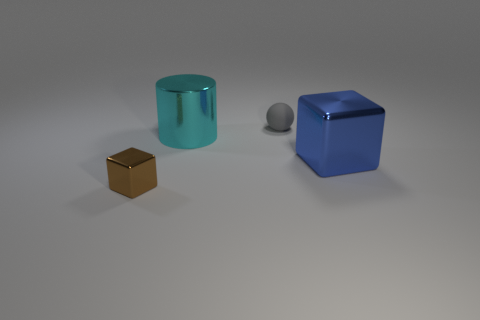Add 4 small gray cylinders. How many objects exist? 8 Subtract 1 cubes. How many cubes are left? 1 Subtract all purple cylinders. How many brown cubes are left? 1 Add 4 large blue rubber spheres. How many large blue rubber spheres exist? 4 Subtract 0 gray cylinders. How many objects are left? 4 Subtract all spheres. How many objects are left? 3 Subtract all yellow cubes. Subtract all yellow spheres. How many cubes are left? 2 Subtract all tiny yellow shiny spheres. Subtract all gray spheres. How many objects are left? 3 Add 2 cubes. How many cubes are left? 4 